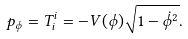<formula> <loc_0><loc_0><loc_500><loc_500>p _ { \phi } = T ^ { i } _ { i } = - V ( \phi ) \sqrt { 1 - \dot { \phi } ^ { 2 } } .</formula> 